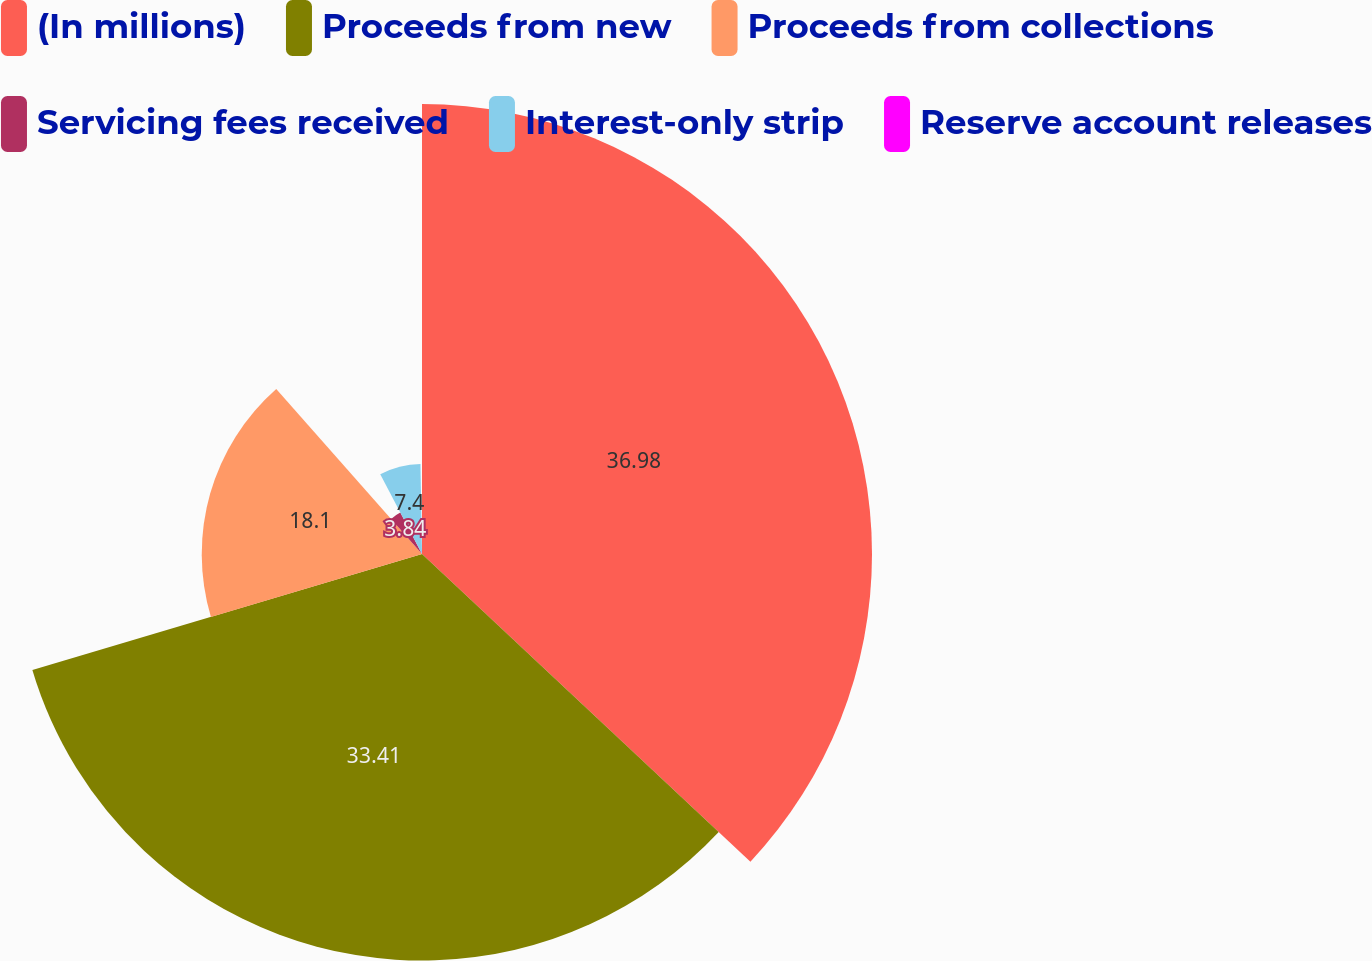Convert chart to OTSL. <chart><loc_0><loc_0><loc_500><loc_500><pie_chart><fcel>(In millions)<fcel>Proceeds from new<fcel>Proceeds from collections<fcel>Servicing fees received<fcel>Interest-only strip<fcel>Reserve account releases<nl><fcel>36.98%<fcel>33.41%<fcel>18.1%<fcel>3.84%<fcel>7.4%<fcel>0.27%<nl></chart> 